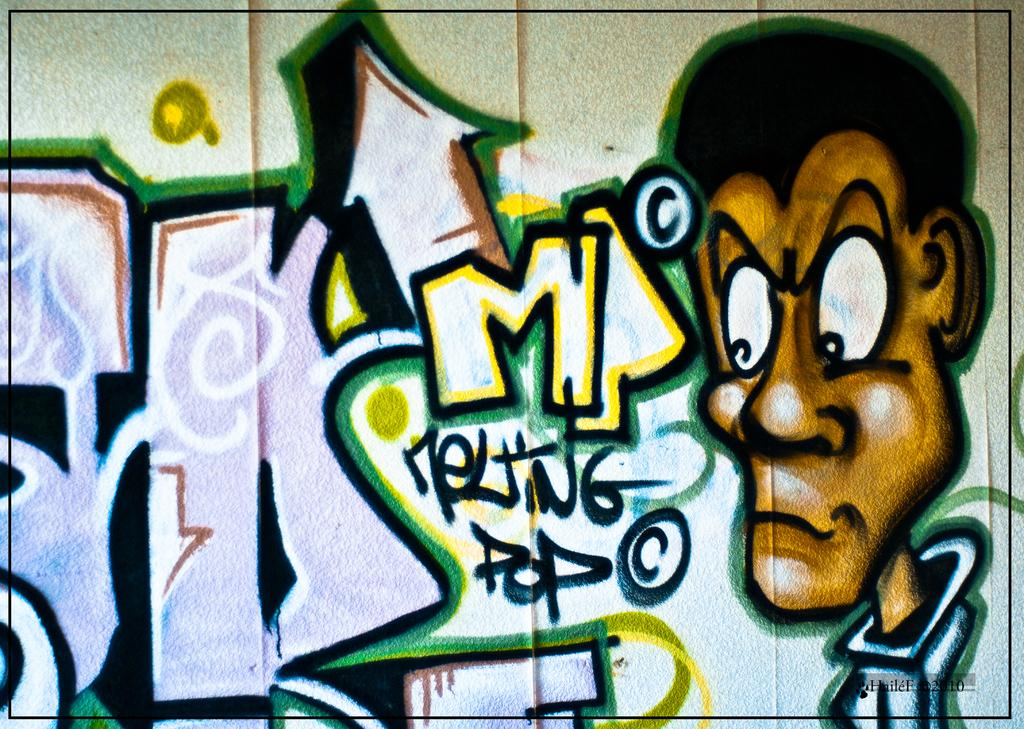What can be seen in the image? There is some art in the image. Can you describe the text in the image? There is text in the bottom right corner of the image. What type of bridge is depicted in the middle of the image? There is no bridge present in the image; it only contains art and text. 